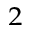<formula> <loc_0><loc_0><loc_500><loc_500>^ { 2 }</formula> 